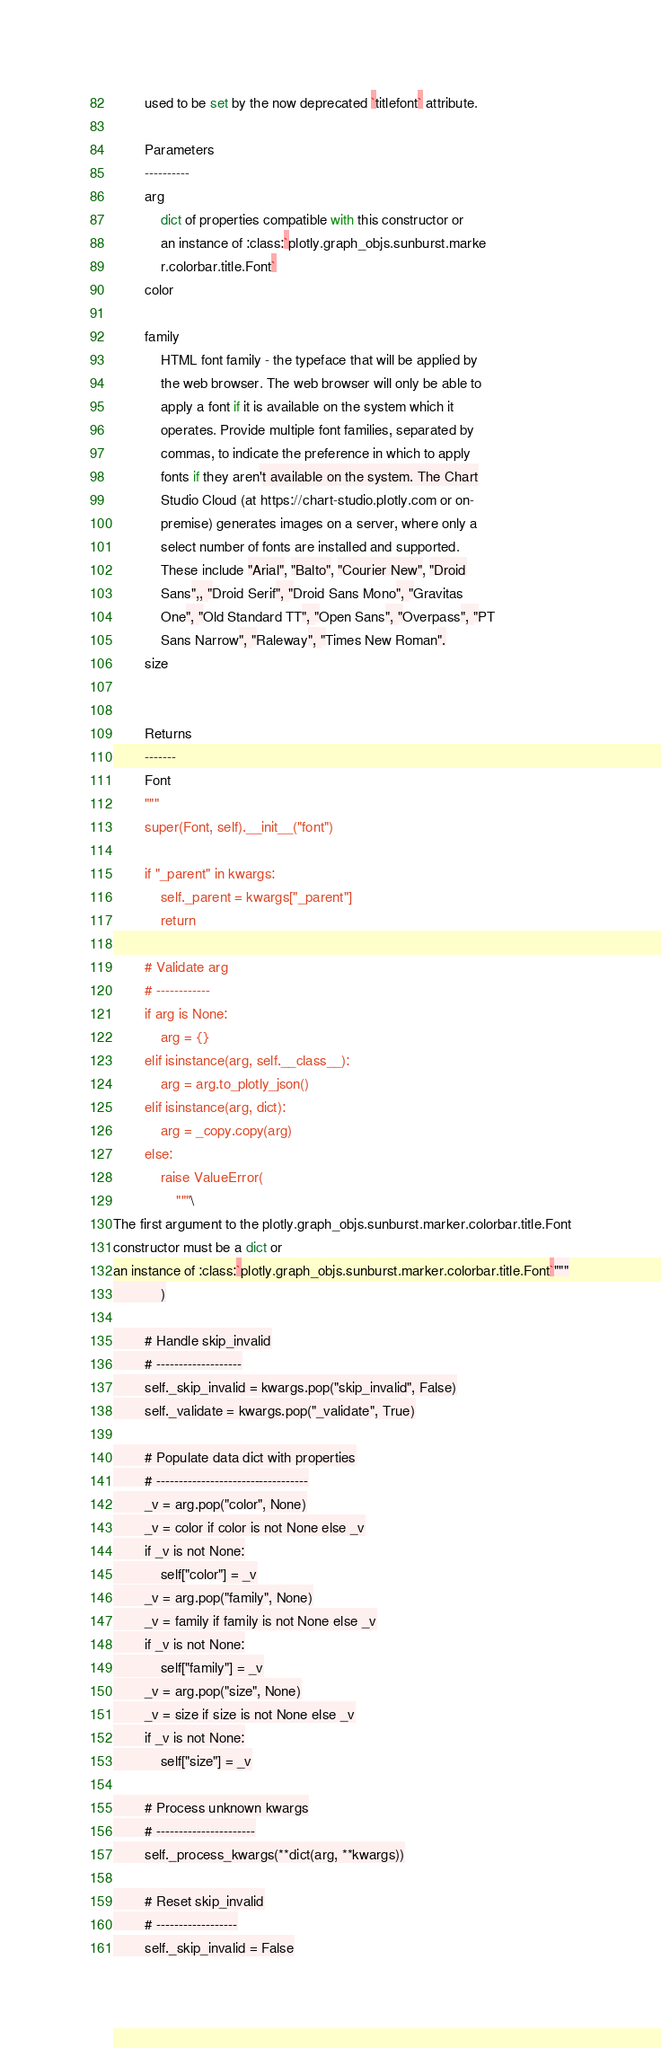Convert code to text. <code><loc_0><loc_0><loc_500><loc_500><_Python_>        used to be set by the now deprecated `titlefont` attribute.

        Parameters
        ----------
        arg
            dict of properties compatible with this constructor or
            an instance of :class:`plotly.graph_objs.sunburst.marke
            r.colorbar.title.Font`
        color

        family
            HTML font family - the typeface that will be applied by
            the web browser. The web browser will only be able to
            apply a font if it is available on the system which it
            operates. Provide multiple font families, separated by
            commas, to indicate the preference in which to apply
            fonts if they aren't available on the system. The Chart
            Studio Cloud (at https://chart-studio.plotly.com or on-
            premise) generates images on a server, where only a
            select number of fonts are installed and supported.
            These include "Arial", "Balto", "Courier New", "Droid
            Sans",, "Droid Serif", "Droid Sans Mono", "Gravitas
            One", "Old Standard TT", "Open Sans", "Overpass", "PT
            Sans Narrow", "Raleway", "Times New Roman".
        size


        Returns
        -------
        Font
        """
        super(Font, self).__init__("font")

        if "_parent" in kwargs:
            self._parent = kwargs["_parent"]
            return

        # Validate arg
        # ------------
        if arg is None:
            arg = {}
        elif isinstance(arg, self.__class__):
            arg = arg.to_plotly_json()
        elif isinstance(arg, dict):
            arg = _copy.copy(arg)
        else:
            raise ValueError(
                """\
The first argument to the plotly.graph_objs.sunburst.marker.colorbar.title.Font
constructor must be a dict or
an instance of :class:`plotly.graph_objs.sunburst.marker.colorbar.title.Font`"""
            )

        # Handle skip_invalid
        # -------------------
        self._skip_invalid = kwargs.pop("skip_invalid", False)
        self._validate = kwargs.pop("_validate", True)

        # Populate data dict with properties
        # ----------------------------------
        _v = arg.pop("color", None)
        _v = color if color is not None else _v
        if _v is not None:
            self["color"] = _v
        _v = arg.pop("family", None)
        _v = family if family is not None else _v
        if _v is not None:
            self["family"] = _v
        _v = arg.pop("size", None)
        _v = size if size is not None else _v
        if _v is not None:
            self["size"] = _v

        # Process unknown kwargs
        # ----------------------
        self._process_kwargs(**dict(arg, **kwargs))

        # Reset skip_invalid
        # ------------------
        self._skip_invalid = False
</code> 